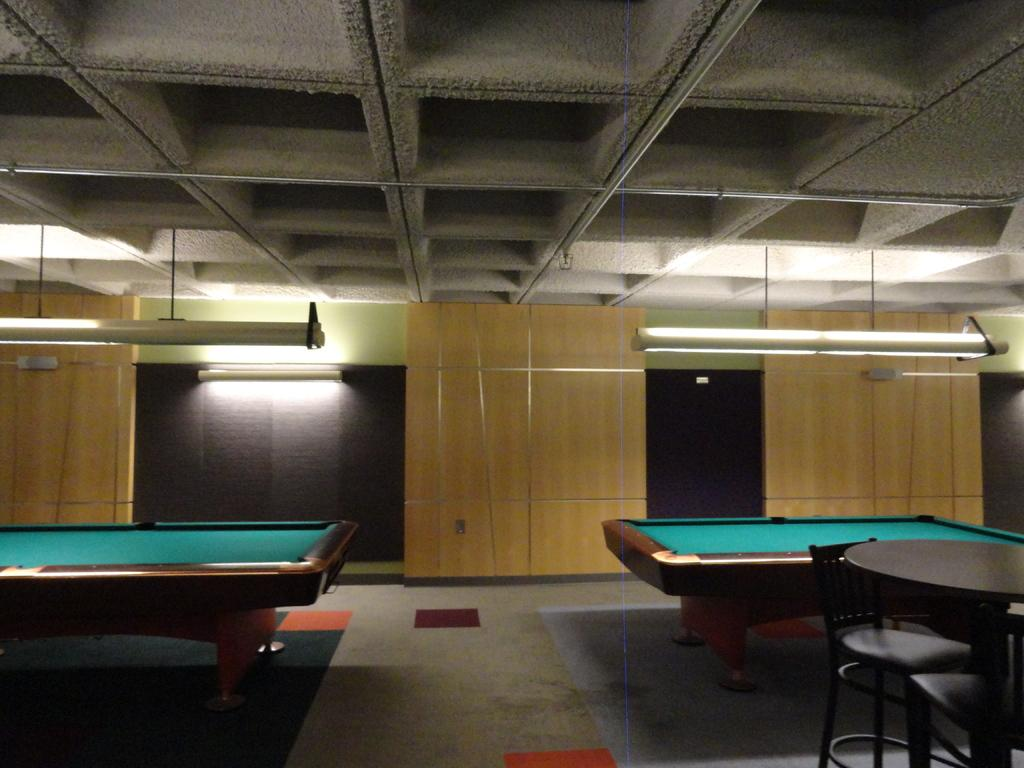How many billiard tables are in the room? There are two billiard tables in the room. What type of furniture is present for seating in the room? There is a table with two chairs in the room. What can be seen providing illumination in the room? There are lights visible in the room. What material is used for the wall in the background? There is a wooden wall in the background. What type of humor does the father use when talking to the guests in the room? There is no mention of a father or guests in the room, nor any indication of humor being used. 